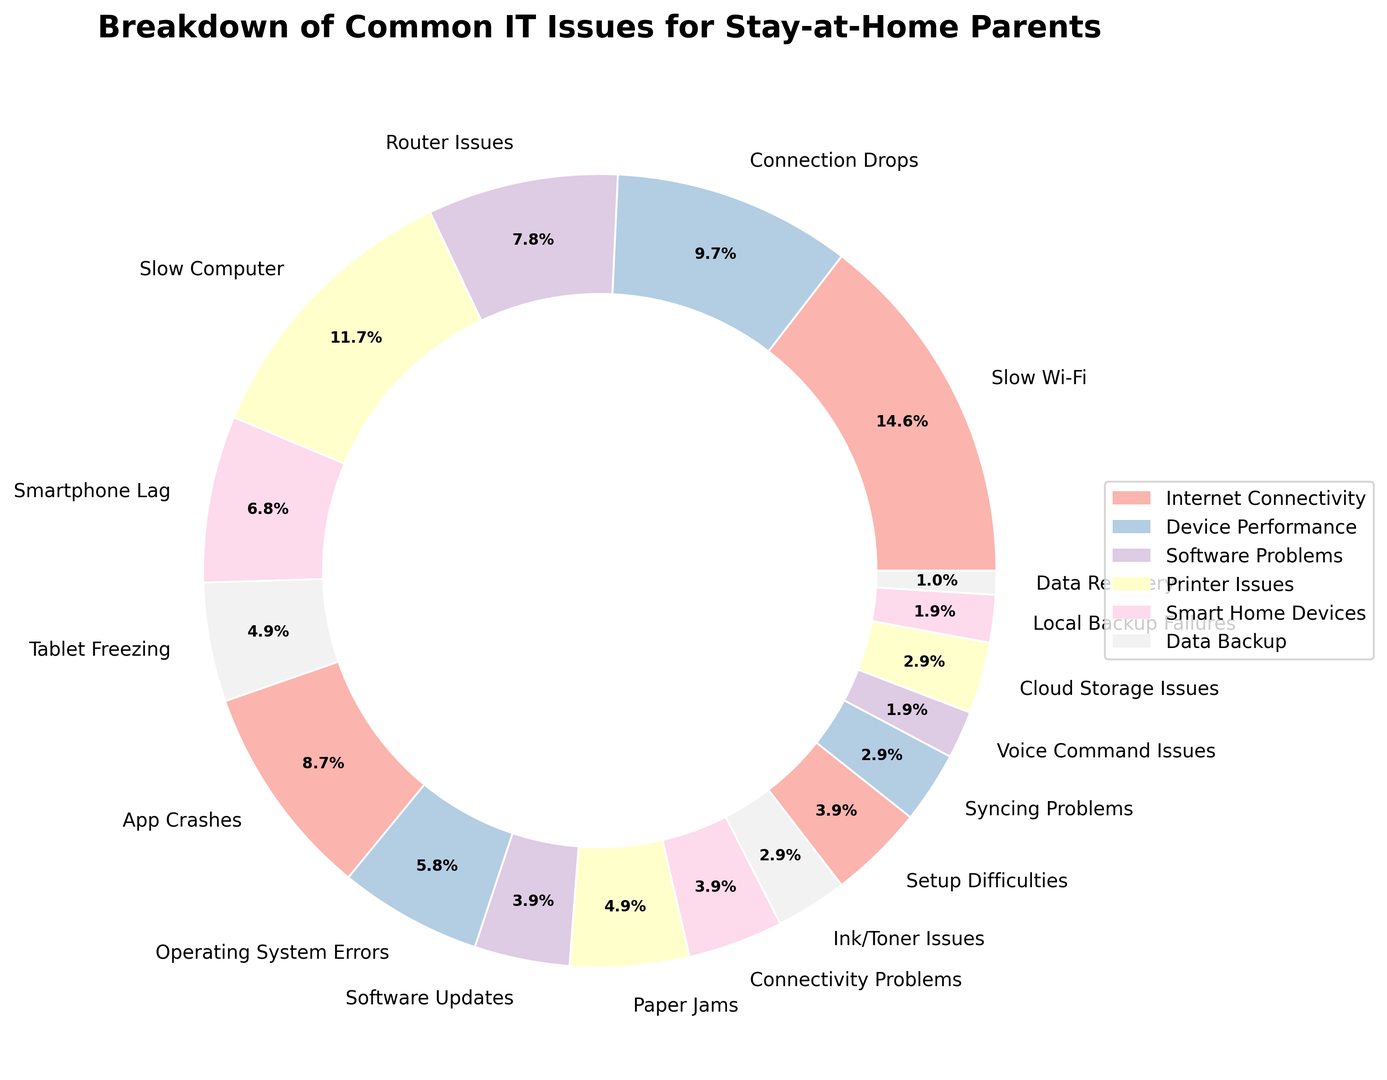What's the most common IT issue faced by stay-at-home parents? The largest segment in the ring chart represents Slow Wi-Fi, indicating it's the most common issue.
Answer: Slow Wi-Fi How many issues are related to printer problems combined? The ring chart shows three subcategories under Printer Issues: Paper Jams (5%), Connectivity Problems (4%), Ink/Toner Issues (3%). Adding these together, 5 + 4 + 3 = 12%.
Answer: 12% Which category has the most issues included in the ring chart? Internet Connectivity has the most subcategories listed (Slow Wi-Fi, Connection Drops, Router Issues) and their percentages sum up to 15 + 10 + 8 = 33%.
Answer: Internet Connectivity Compare the percentage of issues related to slow computers and app crashes. Which one is higher? Slow Computer is 12%, and App Crashes is 9%. Comparing these two, the percentage for Slow Computer is higher.
Answer: Slow Computer What is the total percentage of issues related to Smart Home Devices? Summing up percentages for Smart Home Devices' subcategories: Setup Difficulties (4%), Syncing Problems (3%), Voice Command Issues (2%). 4 + 3 + 2 = 9%.
Answer: 9% Is the combined percentage of issues related to Software Problems higher or lower than those related to Internet Connectivity? Software Problems include App Crashes (9%), Operating System Errors (6%), and Software Updates (4%), totaling 9 + 6 + 4 = 19%. Internet Connectivity issues sum to 33%. Comparing these, Software Problems have a lower combined percentage.
Answer: Lower Which category has issues summing up to the smallest percentage? Data Backup includes Cloud Storage Issues (3%), Local Backup Failures (2%), Data Recovery (1%), for a total of 3 + 2 + 1 = 6%, which is the smallest accumulated percentage.
Answer: Data Backup What's the difference in percentage between Slow Wi-Fi and Slow Computer issues? Slow Wi-Fi is 15% and Slow Computer is 12%. The difference is 15 - 12 = 3%.
Answer: 3% Are there more issues related to Device Performance or Printer Issues? Device Performance includes Slow Computer (12%), Smartphone Lag (7%), and Tablet Freezing (5%), adding up to 12 + 7 + 5 = 24%. Printer Issues add up to 12%. Comparing these totals, Device Performance has more issues.
Answer: Device Performance What is the percentage of Router Issues combined with Voice Command Issues? Router Issues are 8%, and Voice Command Issues are 2%. Adding these together, 8 + 2 = 10%.
Answer: 10% 